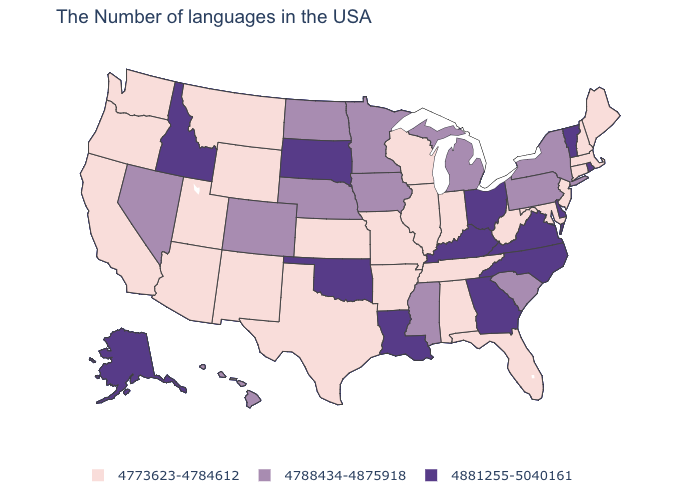Does Montana have the highest value in the USA?
Quick response, please. No. Does the map have missing data?
Concise answer only. No. Does New York have a higher value than New Mexico?
Concise answer only. Yes. Among the states that border Ohio , which have the lowest value?
Give a very brief answer. West Virginia, Indiana. Does the first symbol in the legend represent the smallest category?
Write a very short answer. Yes. What is the lowest value in the Northeast?
Short answer required. 4773623-4784612. Name the states that have a value in the range 4773623-4784612?
Write a very short answer. Maine, Massachusetts, New Hampshire, Connecticut, New Jersey, Maryland, West Virginia, Florida, Indiana, Alabama, Tennessee, Wisconsin, Illinois, Missouri, Arkansas, Kansas, Texas, Wyoming, New Mexico, Utah, Montana, Arizona, California, Washington, Oregon. Does Minnesota have the lowest value in the MidWest?
Short answer required. No. Does the first symbol in the legend represent the smallest category?
Be succinct. Yes. Among the states that border New York , which have the highest value?
Short answer required. Vermont. What is the value of Ohio?
Short answer required. 4881255-5040161. Name the states that have a value in the range 4881255-5040161?
Write a very short answer. Rhode Island, Vermont, Delaware, Virginia, North Carolina, Ohio, Georgia, Kentucky, Louisiana, Oklahoma, South Dakota, Idaho, Alaska. How many symbols are there in the legend?
Give a very brief answer. 3. Name the states that have a value in the range 4788434-4875918?
Quick response, please. New York, Pennsylvania, South Carolina, Michigan, Mississippi, Minnesota, Iowa, Nebraska, North Dakota, Colorado, Nevada, Hawaii. Name the states that have a value in the range 4881255-5040161?
Write a very short answer. Rhode Island, Vermont, Delaware, Virginia, North Carolina, Ohio, Georgia, Kentucky, Louisiana, Oklahoma, South Dakota, Idaho, Alaska. 